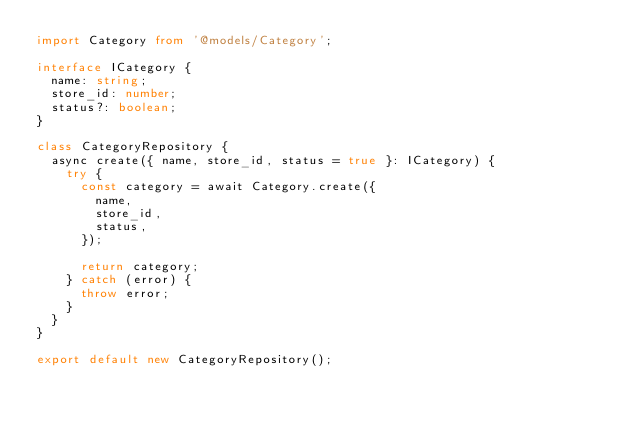Convert code to text. <code><loc_0><loc_0><loc_500><loc_500><_TypeScript_>import Category from '@models/Category';

interface ICategory {
  name: string;
  store_id: number;
  status?: boolean;
}

class CategoryRepository {
  async create({ name, store_id, status = true }: ICategory) {
    try {
      const category = await Category.create({
        name,
        store_id,
        status,
      });

      return category;
    } catch (error) {
      throw error;
    }
  }
}

export default new CategoryRepository();
</code> 